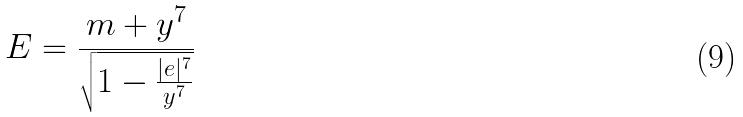Convert formula to latex. <formula><loc_0><loc_0><loc_500><loc_500>E = \frac { m + y ^ { 7 } } { \sqrt { 1 - \frac { | e | ^ { 7 } } { y ^ { 7 } } } }</formula> 